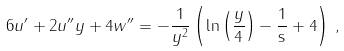<formula> <loc_0><loc_0><loc_500><loc_500>6 u ^ { \prime } + 2 u ^ { \prime \prime } y + 4 w ^ { \prime \prime } = - \frac { 1 } { y ^ { 2 } } \left ( \ln \left ( \frac { y } { 4 } \right ) - \frac { 1 } { \tt s } + 4 \right ) \, ,</formula> 